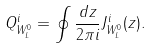Convert formula to latex. <formula><loc_0><loc_0><loc_500><loc_500>Q _ { W _ { L } ^ { 0 } } ^ { i } = \oint \frac { d z } { 2 \pi i } J _ { W _ { L } ^ { 0 } } ^ { i } ( z ) .</formula> 